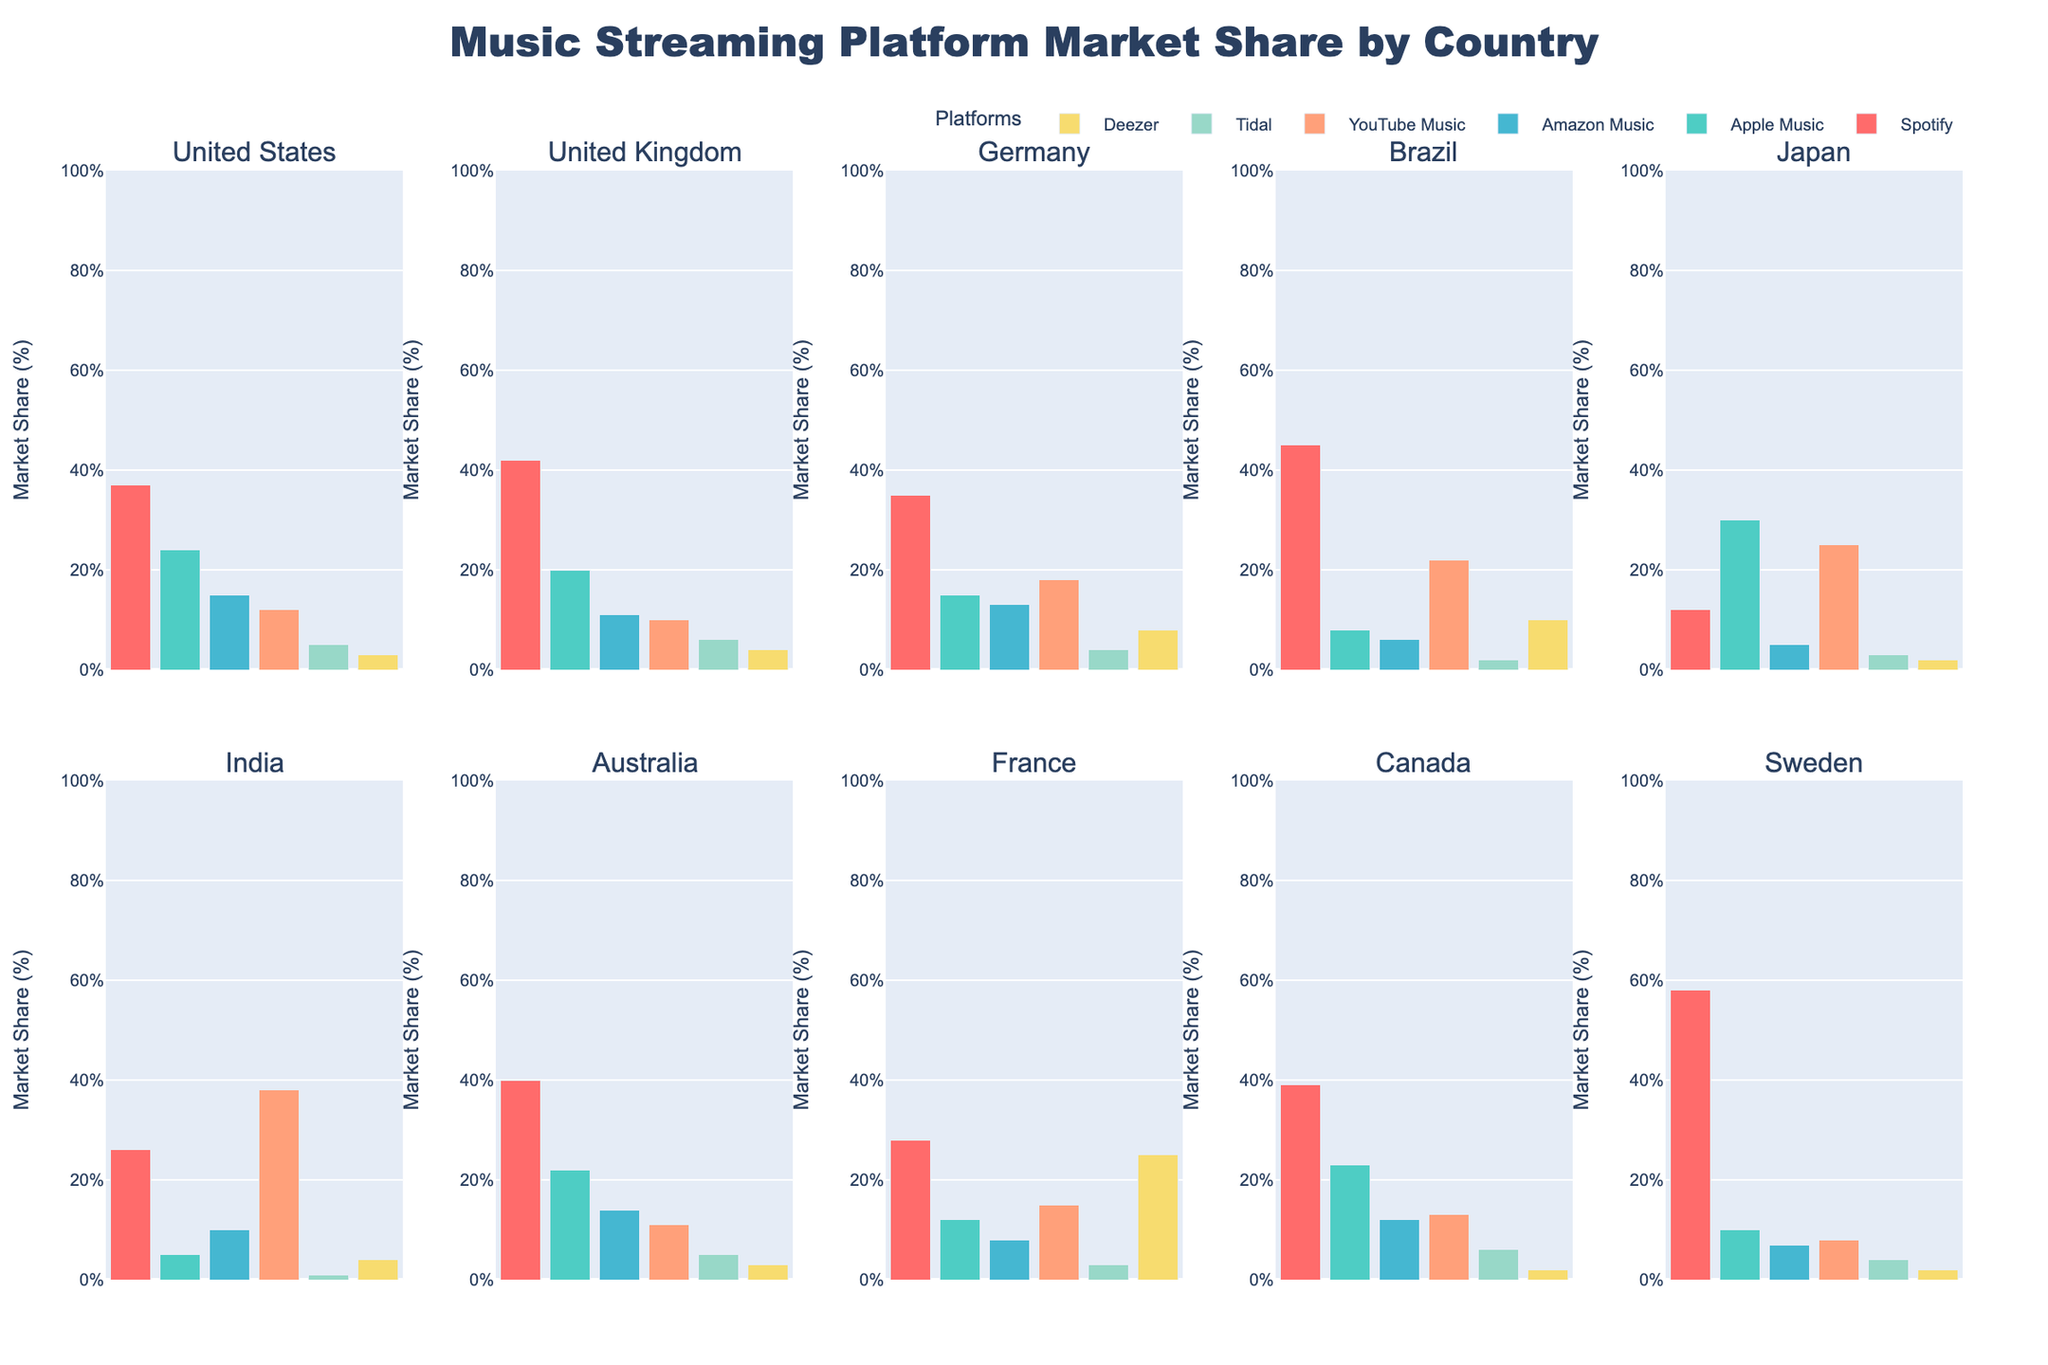What is the most popular music streaming platform in Brazil? By observing the bar heights for each platform in Brazil, we can see that the bar corresponding to Spotify is the tallest, indicating a 45% market share, making it the most popular platform.
Answer: Spotify How does YouTube Music's market share in Japan compare to that in the United States? In Japan, YouTube Music has a 25% market share, whereas in the United States, it has a 12% market share. Comparing these values, YouTube Music has a higher market share in Japan.
Answer: Japan > United States What is the sum of market shares for Spotify and Apple Music in India? The market share for Spotify in India is 26% and for Apple Music is 5%. Adding these two percentages together, we get 26% + 5% = 31%.
Answer: 31% Which country has the highest market share for Deezer? By comparing the heights of the Deezer bars across all countries, France has the tallest bar at 25%, indicating the highest market share for Deezer.
Answer: France What is the difference in market share between Spotify and Amazon Music in Germany? In Germany, Spotify has a 35% market share and Amazon Music has a 13% market share. The difference is 35% - 13% = 22%.
Answer: 22% In which country is Tidal more popular: the United Kingdom or Australia? The Tidal bar is taller in the United Kingdom at 6% compared to 5% in Australia, making Tidal slightly more popular in the United Kingdom.
Answer: United Kingdom Which platform has the lowest market share in Canada? The bar representing the lowest height in Canada corresponds to Deezer, with a market share of 2%.
Answer: Deezer What is the average market share for YouTube Music across all the countries? Summing up the YouTube Music market share percentages across all countries: 12% + 10% + 18% + 22% + 25% + 38% + 11% + 15% + 13% + 8% = 172%. There are 10 countries, so the average market share is 172% / 10 = 17.2%.
Answer: 17.2% How does Spotify's market share in Sweden compare to its share in Japan? Spotify's market share in Sweden is 58%, and in Japan, it is 12%. Therefore, Spotify's market share is much higher in Sweden.
Answer: Sweden > Japan Which countries have an equal market share for Tidal and what is that share? Tidal has a 4% market share in both Germany and Sweden, as observed by the similar heights of the Tidal bars in these countries.
Answer: Germany and Sweden, 4% 